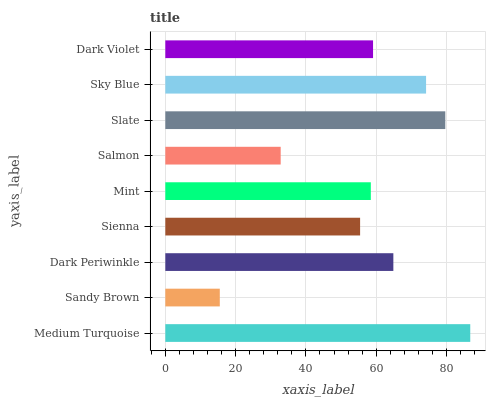Is Sandy Brown the minimum?
Answer yes or no. Yes. Is Medium Turquoise the maximum?
Answer yes or no. Yes. Is Dark Periwinkle the minimum?
Answer yes or no. No. Is Dark Periwinkle the maximum?
Answer yes or no. No. Is Dark Periwinkle greater than Sandy Brown?
Answer yes or no. Yes. Is Sandy Brown less than Dark Periwinkle?
Answer yes or no. Yes. Is Sandy Brown greater than Dark Periwinkle?
Answer yes or no. No. Is Dark Periwinkle less than Sandy Brown?
Answer yes or no. No. Is Dark Violet the high median?
Answer yes or no. Yes. Is Dark Violet the low median?
Answer yes or no. Yes. Is Mint the high median?
Answer yes or no. No. Is Medium Turquoise the low median?
Answer yes or no. No. 